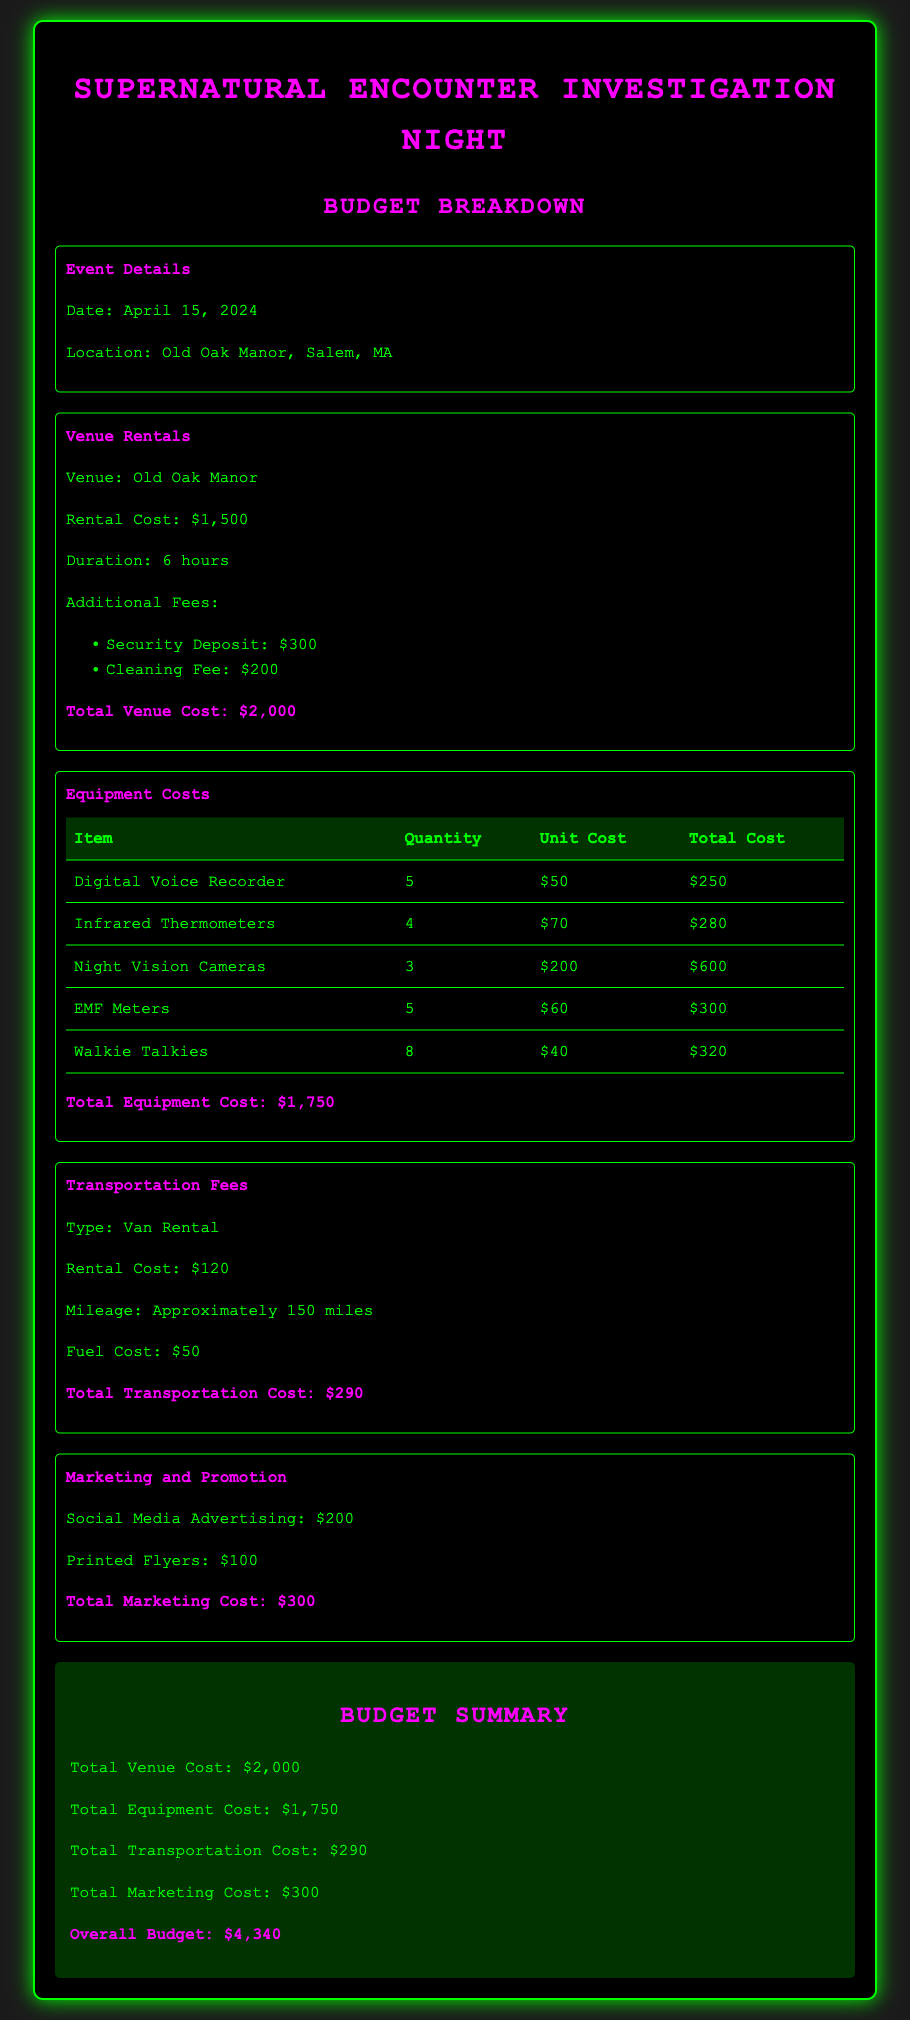What is the rental cost of the venue? The rental cost of the venue, Old Oak Manor, is specified in the document as $1,500.
Answer: $1,500 What is the total cost for equipment? The total cost for equipment is found by summing individual equipment costs, resulting in $1,750.
Answer: $1,750 How many infrared thermometers are rented? The document lists 4 infrared thermometers as part of the equipment costs.
Answer: 4 What is the total transportation cost? The total transportation cost is detailed in the document as $290, which includes van rental and fuel costs.
Answer: $290 What is the date of the event? The date of the supernatural investigation event is clearly indicated in the document as April 15, 2024.
Answer: April 15, 2024 What additional fee is mentioned for the venue rental? The document specifies a Security Deposit of $300 as an additional fee for the venue rental.
Answer: $300 What is the total marketing cost? The total marketing cost, which includes social media advertising and printed flyers, amounts to $300.
Answer: $300 What is the total overall budget for the event? The overall budget is summarized in the document as the sum of various costs, totaling $4,340.
Answer: $4,340 How many walkie talkies are rented? The budget document states that 8 walkie talkies are included in the equipment rental.
Answer: 8 